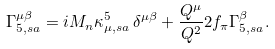Convert formula to latex. <formula><loc_0><loc_0><loc_500><loc_500>\Gamma ^ { \mu \beta } _ { 5 , s a } = i M _ { n } \kappa ^ { 5 } _ { \mu , s a } \, \delta ^ { \mu \beta } + \frac { Q ^ { \mu } } { Q ^ { 2 } } 2 f _ { \pi } \Gamma ^ { \beta } _ { 5 , s a } .</formula> 